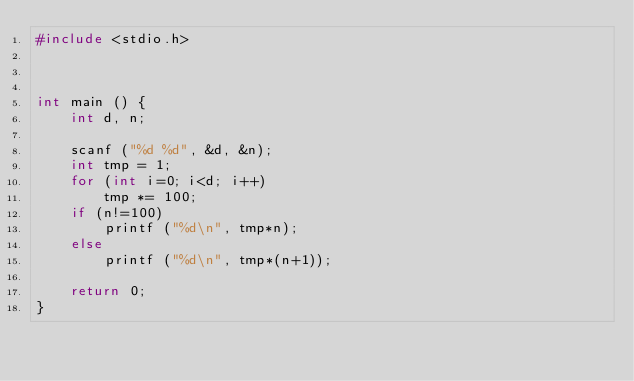Convert code to text. <code><loc_0><loc_0><loc_500><loc_500><_C_>#include <stdio.h>



int main () {
	int d, n;

	scanf ("%d %d", &d, &n);
	int tmp = 1;
	for (int i=0; i<d; i++)
		tmp *= 100;
	if (n!=100)
		printf ("%d\n", tmp*n);
	else
		printf ("%d\n", tmp*(n+1));

	return 0;
}
</code> 